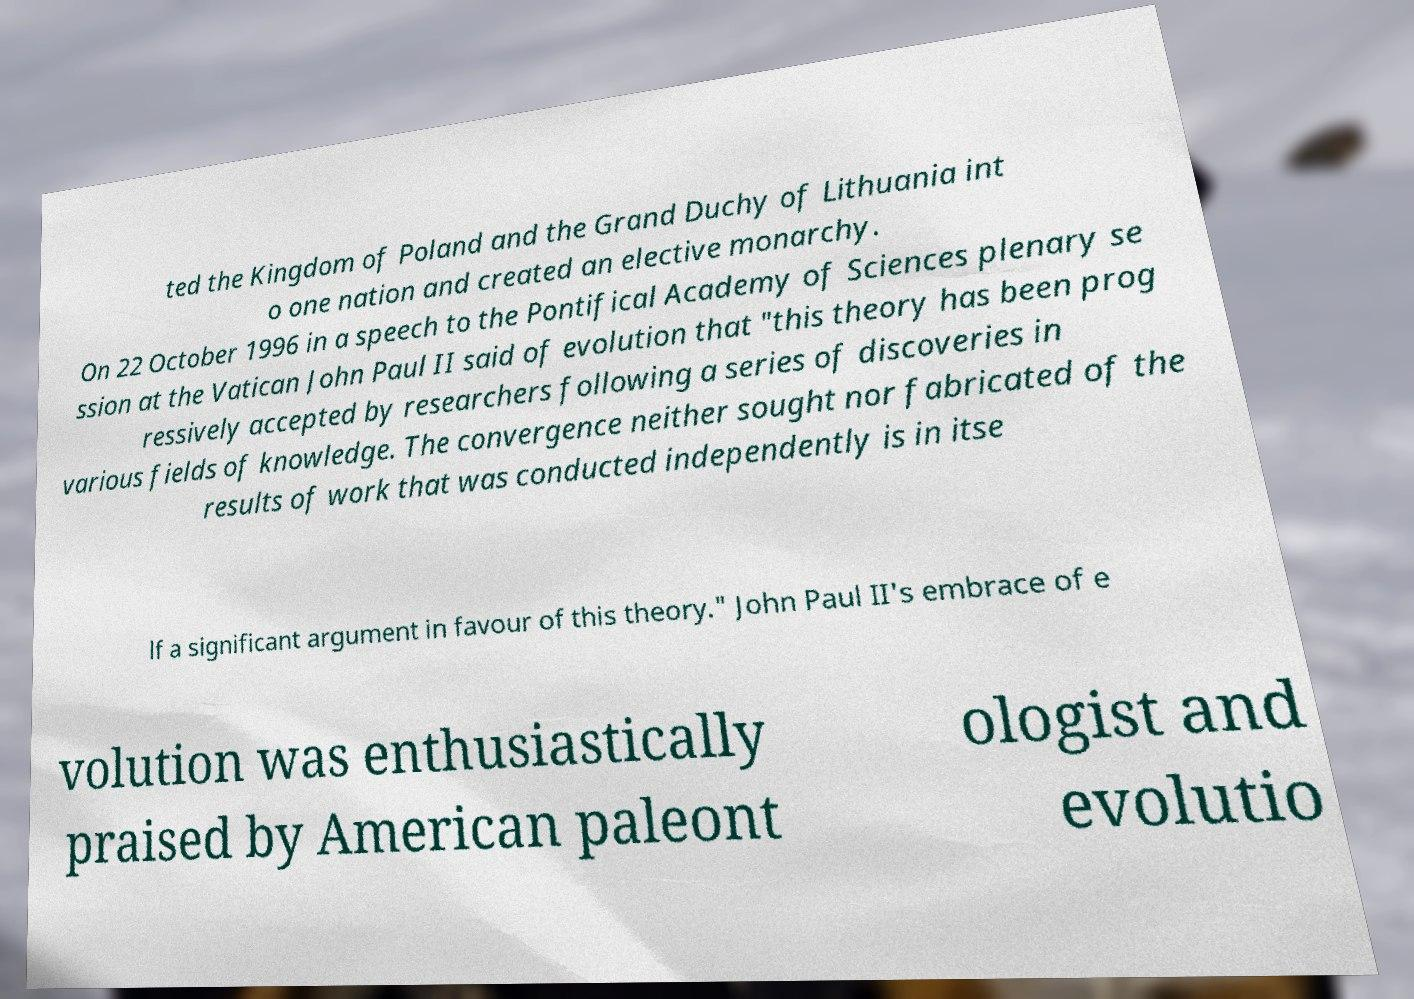What messages or text are displayed in this image? I need them in a readable, typed format. ted the Kingdom of Poland and the Grand Duchy of Lithuania int o one nation and created an elective monarchy. On 22 October 1996 in a speech to the Pontifical Academy of Sciences plenary se ssion at the Vatican John Paul II said of evolution that "this theory has been prog ressively accepted by researchers following a series of discoveries in various fields of knowledge. The convergence neither sought nor fabricated of the results of work that was conducted independently is in itse lf a significant argument in favour of this theory." John Paul II's embrace of e volution was enthusiastically praised by American paleont ologist and evolutio 